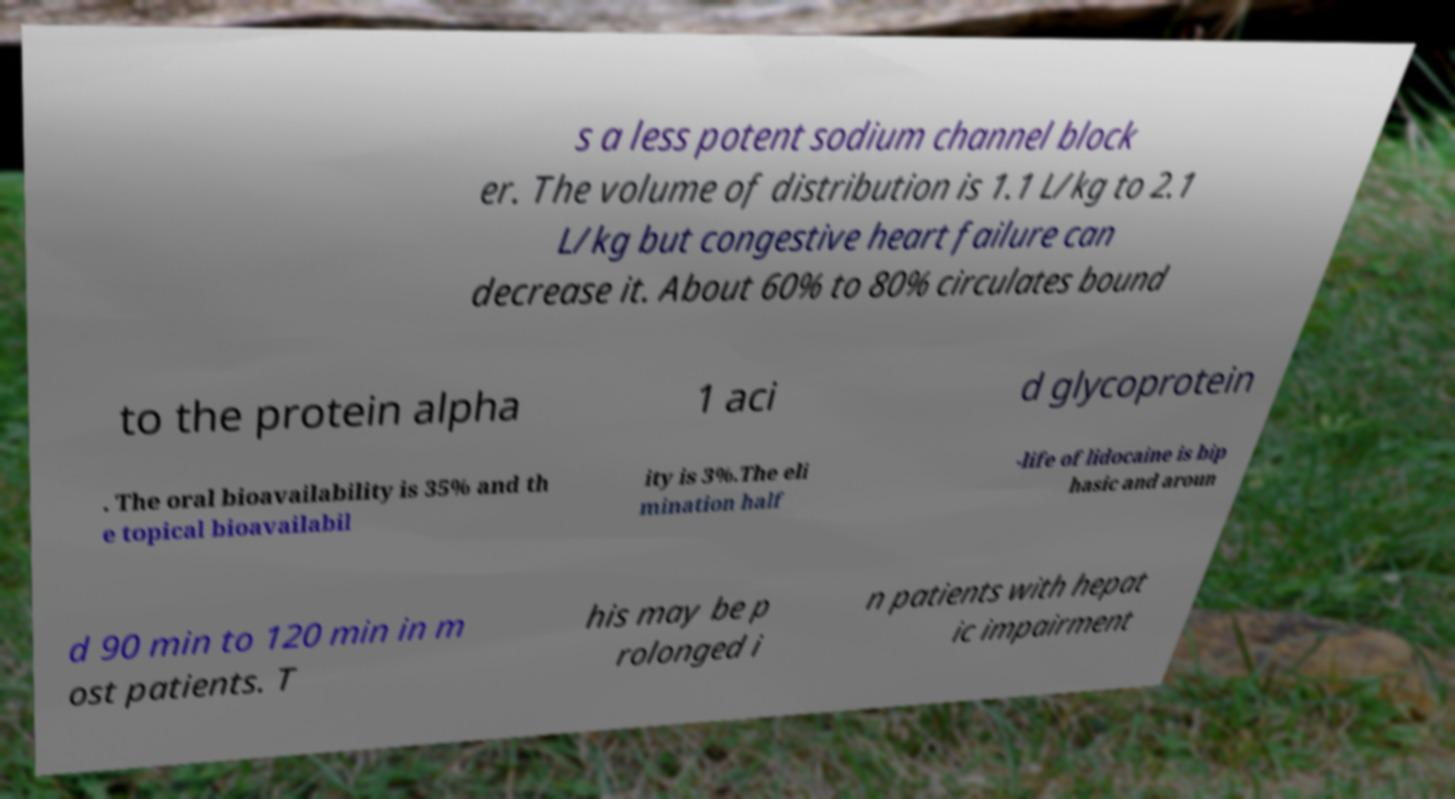I need the written content from this picture converted into text. Can you do that? s a less potent sodium channel block er. The volume of distribution is 1.1 L/kg to 2.1 L/kg but congestive heart failure can decrease it. About 60% to 80% circulates bound to the protein alpha 1 aci d glycoprotein . The oral bioavailability is 35% and th e topical bioavailabil ity is 3%.The eli mination half -life of lidocaine is bip hasic and aroun d 90 min to 120 min in m ost patients. T his may be p rolonged i n patients with hepat ic impairment 